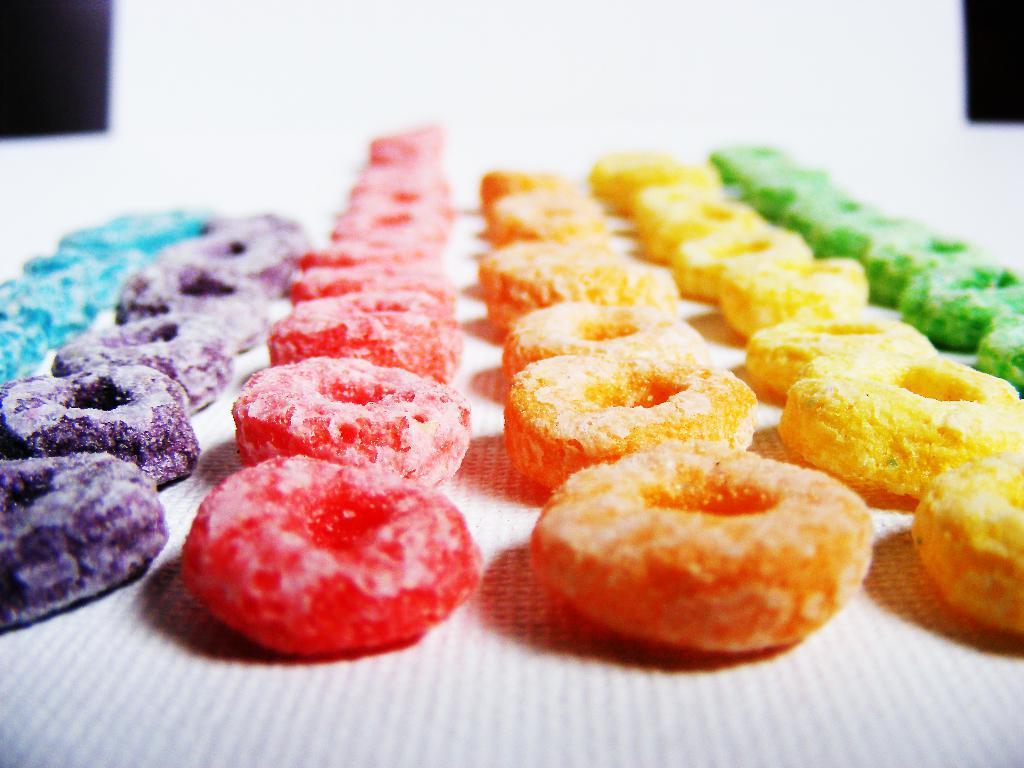Could you give a brief overview of what you see in this image? In this image there are different colors of candies arranged in rows. Candies are on a paper. Background there is a wall. 